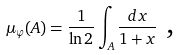Convert formula to latex. <formula><loc_0><loc_0><loc_500><loc_500>\ \mu _ { \varphi } ( A ) = \frac { 1 } { \ln 2 } \int _ { A } \frac { d x } { 1 + x } \text { ,}</formula> 